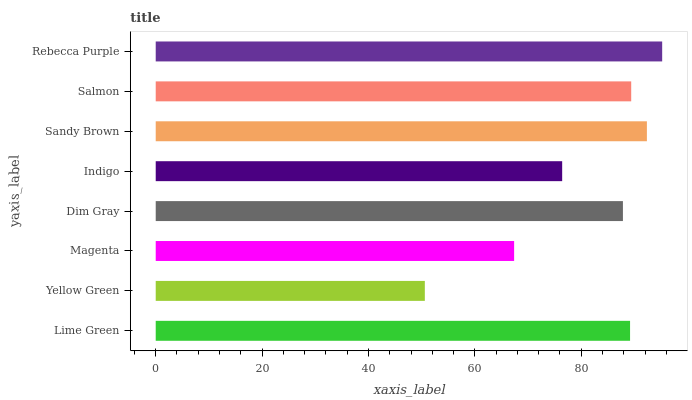Is Yellow Green the minimum?
Answer yes or no. Yes. Is Rebecca Purple the maximum?
Answer yes or no. Yes. Is Magenta the minimum?
Answer yes or no. No. Is Magenta the maximum?
Answer yes or no. No. Is Magenta greater than Yellow Green?
Answer yes or no. Yes. Is Yellow Green less than Magenta?
Answer yes or no. Yes. Is Yellow Green greater than Magenta?
Answer yes or no. No. Is Magenta less than Yellow Green?
Answer yes or no. No. Is Lime Green the high median?
Answer yes or no. Yes. Is Dim Gray the low median?
Answer yes or no. Yes. Is Sandy Brown the high median?
Answer yes or no. No. Is Salmon the low median?
Answer yes or no. No. 